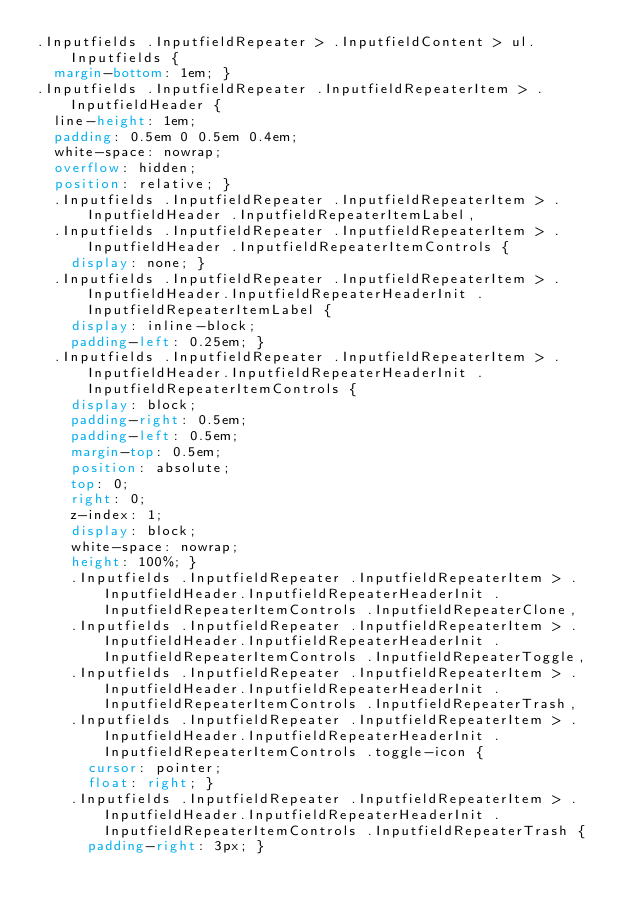<code> <loc_0><loc_0><loc_500><loc_500><_CSS_>.Inputfields .InputfieldRepeater > .InputfieldContent > ul.Inputfields {
  margin-bottom: 1em; }
.Inputfields .InputfieldRepeater .InputfieldRepeaterItem > .InputfieldHeader {
  line-height: 1em;
  padding: 0.5em 0 0.5em 0.4em;
  white-space: nowrap;
  overflow: hidden;
  position: relative; }
  .Inputfields .InputfieldRepeater .InputfieldRepeaterItem > .InputfieldHeader .InputfieldRepeaterItemLabel,
  .Inputfields .InputfieldRepeater .InputfieldRepeaterItem > .InputfieldHeader .InputfieldRepeaterItemControls {
    display: none; }
  .Inputfields .InputfieldRepeater .InputfieldRepeaterItem > .InputfieldHeader.InputfieldRepeaterHeaderInit .InputfieldRepeaterItemLabel {
    display: inline-block;
    padding-left: 0.25em; }
  .Inputfields .InputfieldRepeater .InputfieldRepeaterItem > .InputfieldHeader.InputfieldRepeaterHeaderInit .InputfieldRepeaterItemControls {
    display: block;
    padding-right: 0.5em;
    padding-left: 0.5em;
    margin-top: 0.5em;
    position: absolute;
    top: 0;
    right: 0;
    z-index: 1;
    display: block;
    white-space: nowrap;
    height: 100%; }
    .Inputfields .InputfieldRepeater .InputfieldRepeaterItem > .InputfieldHeader.InputfieldRepeaterHeaderInit .InputfieldRepeaterItemControls .InputfieldRepeaterClone,
    .Inputfields .InputfieldRepeater .InputfieldRepeaterItem > .InputfieldHeader.InputfieldRepeaterHeaderInit .InputfieldRepeaterItemControls .InputfieldRepeaterToggle,
    .Inputfields .InputfieldRepeater .InputfieldRepeaterItem > .InputfieldHeader.InputfieldRepeaterHeaderInit .InputfieldRepeaterItemControls .InputfieldRepeaterTrash,
    .Inputfields .InputfieldRepeater .InputfieldRepeaterItem > .InputfieldHeader.InputfieldRepeaterHeaderInit .InputfieldRepeaterItemControls .toggle-icon {
      cursor: pointer;
      float: right; }
    .Inputfields .InputfieldRepeater .InputfieldRepeaterItem > .InputfieldHeader.InputfieldRepeaterHeaderInit .InputfieldRepeaterItemControls .InputfieldRepeaterTrash {
      padding-right: 3px; }</code> 